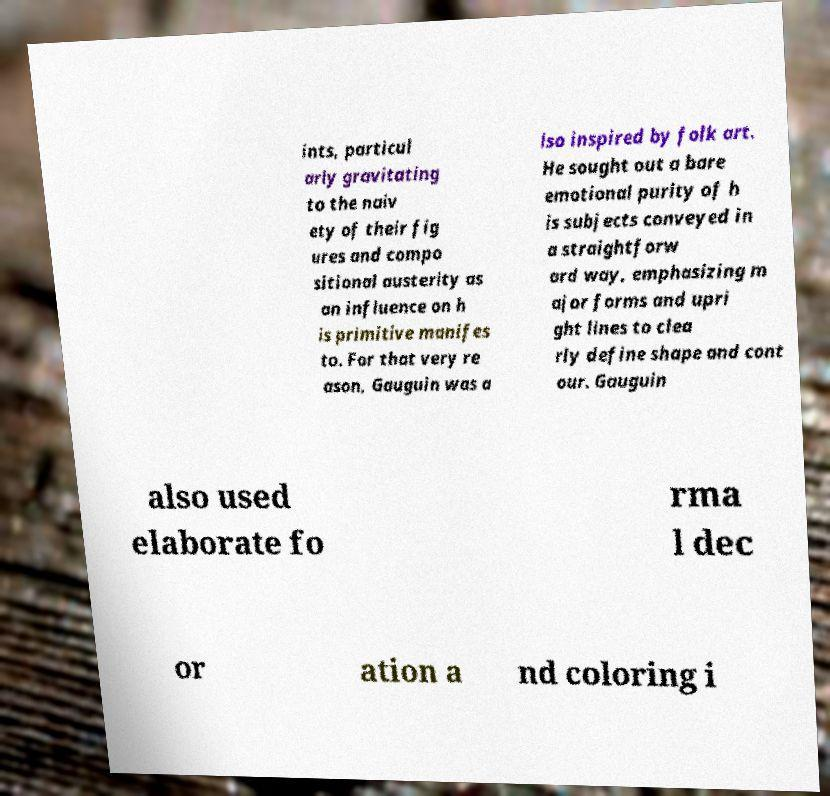There's text embedded in this image that I need extracted. Can you transcribe it verbatim? ints, particul arly gravitating to the naiv ety of their fig ures and compo sitional austerity as an influence on h is primitive manifes to. For that very re ason, Gauguin was a lso inspired by folk art. He sought out a bare emotional purity of h is subjects conveyed in a straightforw ard way, emphasizing m ajor forms and upri ght lines to clea rly define shape and cont our. Gauguin also used elaborate fo rma l dec or ation a nd coloring i 